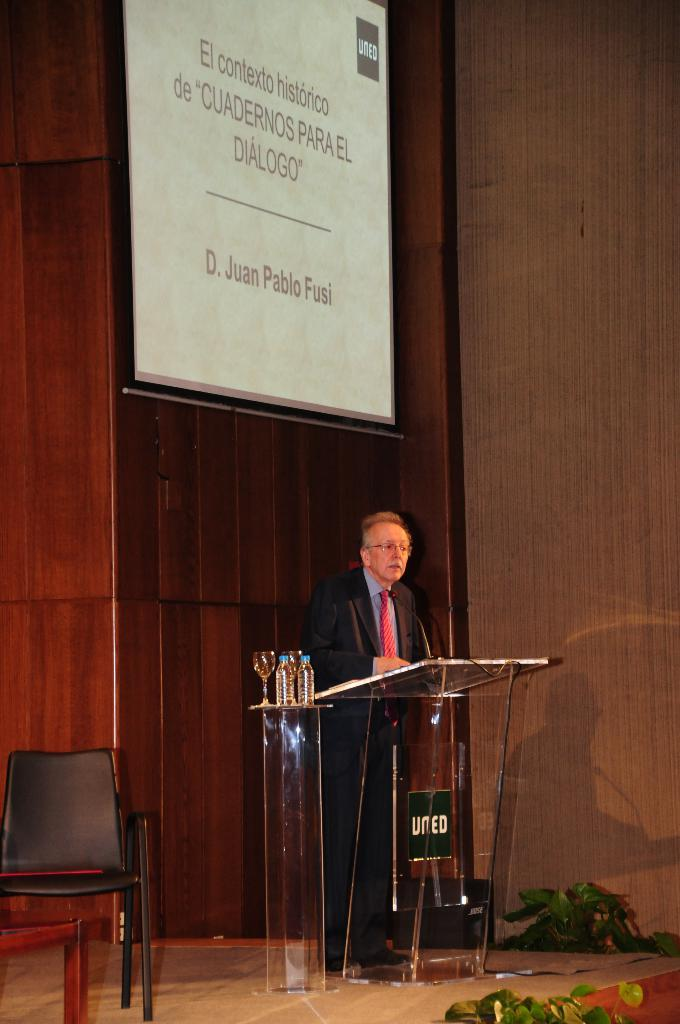What is the main subject of the image? The main subject of the image is a man. What is the man doing in the image? The man is standing in the image. What object is present in front of the man? There is a podium in front of the man. What type of degree is the man holding in the image? There is no indication in the image that the man is holding a degree. What is the man's purpose for standing near the podium in the image? The image does not provide information about the man's purpose for standing near the podium. 